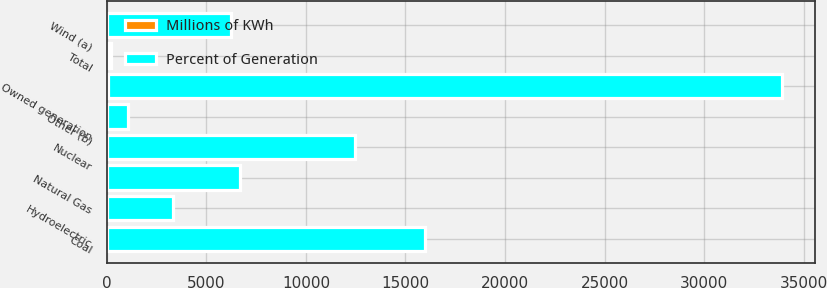Convert chart to OTSL. <chart><loc_0><loc_0><loc_500><loc_500><stacked_bar_chart><ecel><fcel>Coal<fcel>Nuclear<fcel>Natural Gas<fcel>Wind (a)<fcel>Hydroelectric<fcel>Other (b)<fcel>Total<fcel>Owned generation<nl><fcel>Percent of Generation<fcel>15961<fcel>12425<fcel>6689<fcel>6235<fcel>3326<fcel>1083<fcel>100<fcel>33818<nl><fcel>Millions of KWh<fcel>35<fcel>27<fcel>15<fcel>14<fcel>7<fcel>2<fcel>100<fcel>74<nl></chart> 